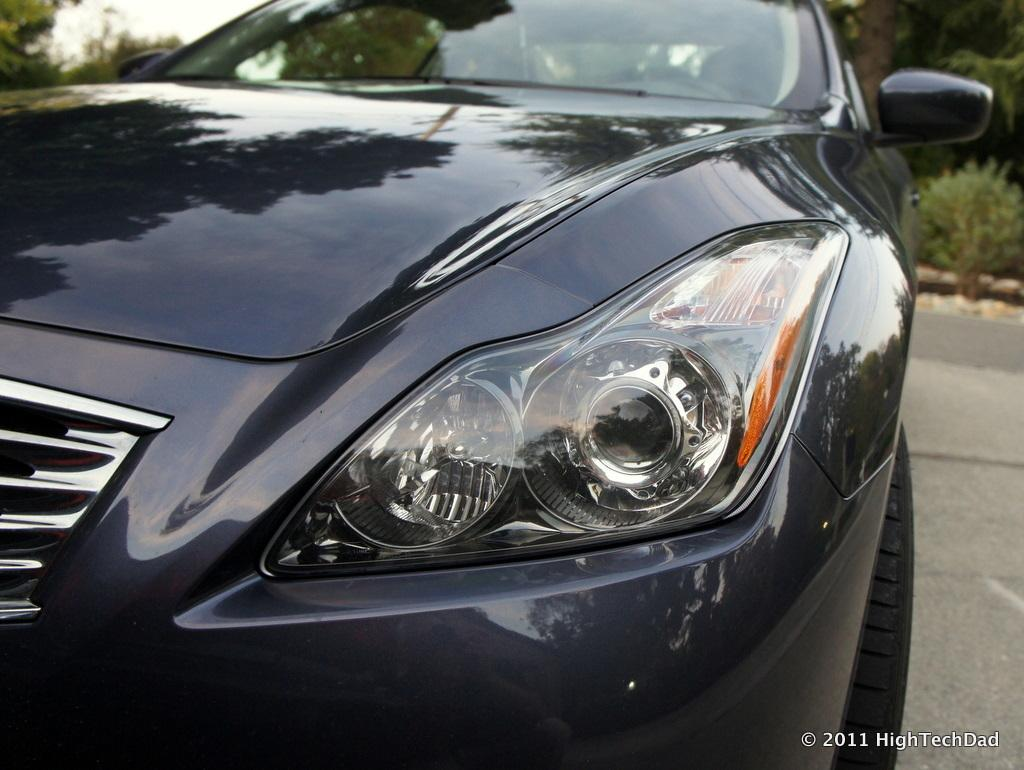What type of vehicle is in the image? There is a black car in the image. What can be seen in the background of the image? There are trees in the background of the image. Where is the car located in the image? The car is on the road. What activity are the ducks participating in near the car in the image? There are no ducks present in the image, so no such activity can be observed. 